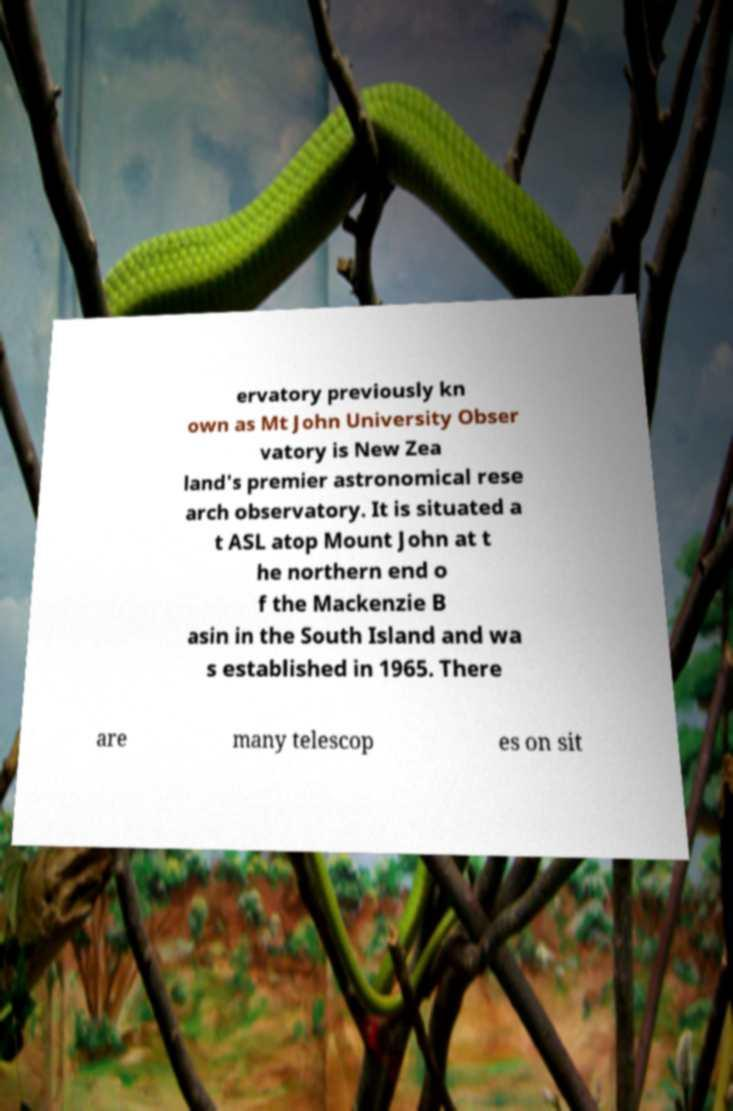Can you accurately transcribe the text from the provided image for me? ervatory previously kn own as Mt John University Obser vatory is New Zea land's premier astronomical rese arch observatory. It is situated a t ASL atop Mount John at t he northern end o f the Mackenzie B asin in the South Island and wa s established in 1965. There are many telescop es on sit 